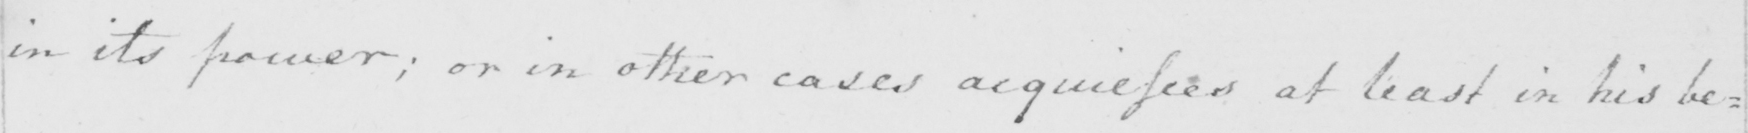Can you tell me what this handwritten text says? in its power ; or in other cases acquiesces at least in his be : 